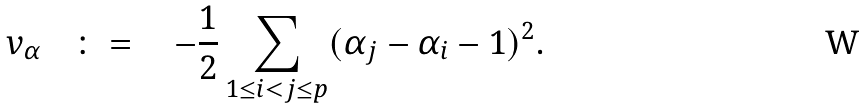Convert formula to latex. <formula><loc_0><loc_0><loc_500><loc_500>v _ { \alpha } \quad \colon = \quad - \frac { 1 } { 2 } \sum _ { 1 \leq i < j \leq p } ( \alpha _ { j } - \alpha _ { i } - 1 ) ^ { 2 } .</formula> 